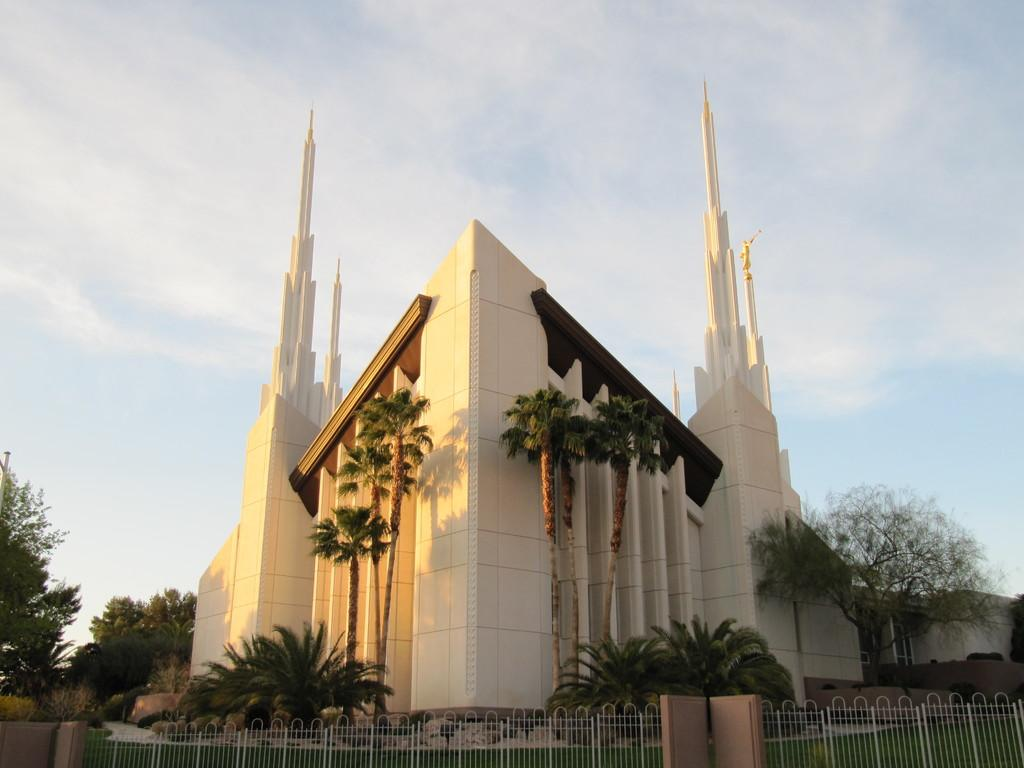What type of structure can be seen in the image? There is a fencing in the image. What type of natural environment is visible in the image? There is grass and trees in the image. What type of man-made structure is visible in the image? There is a building in the image. What type of tin can be seen in the image? There is no tin present in the image. Is there a railway visible in the image? There is no railway present in the image. 